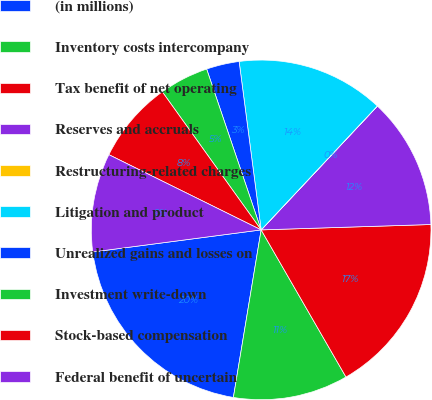Convert chart to OTSL. <chart><loc_0><loc_0><loc_500><loc_500><pie_chart><fcel>(in millions)<fcel>Inventory costs intercompany<fcel>Tax benefit of net operating<fcel>Reserves and accruals<fcel>Restructuring-related charges<fcel>Litigation and product<fcel>Unrealized gains and losses on<fcel>Investment write-down<fcel>Stock-based compensation<fcel>Federal benefit of uncertain<nl><fcel>20.31%<fcel>10.94%<fcel>17.18%<fcel>12.5%<fcel>0.01%<fcel>14.06%<fcel>3.13%<fcel>4.69%<fcel>7.81%<fcel>9.38%<nl></chart> 